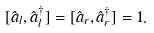Convert formula to latex. <formula><loc_0><loc_0><loc_500><loc_500>[ \hat { a } _ { l } , \hat { a } _ { l } ^ { \dagger } ] = [ \hat { a } _ { r } , \hat { a } _ { r } ^ { \dagger } ] = 1 .</formula> 